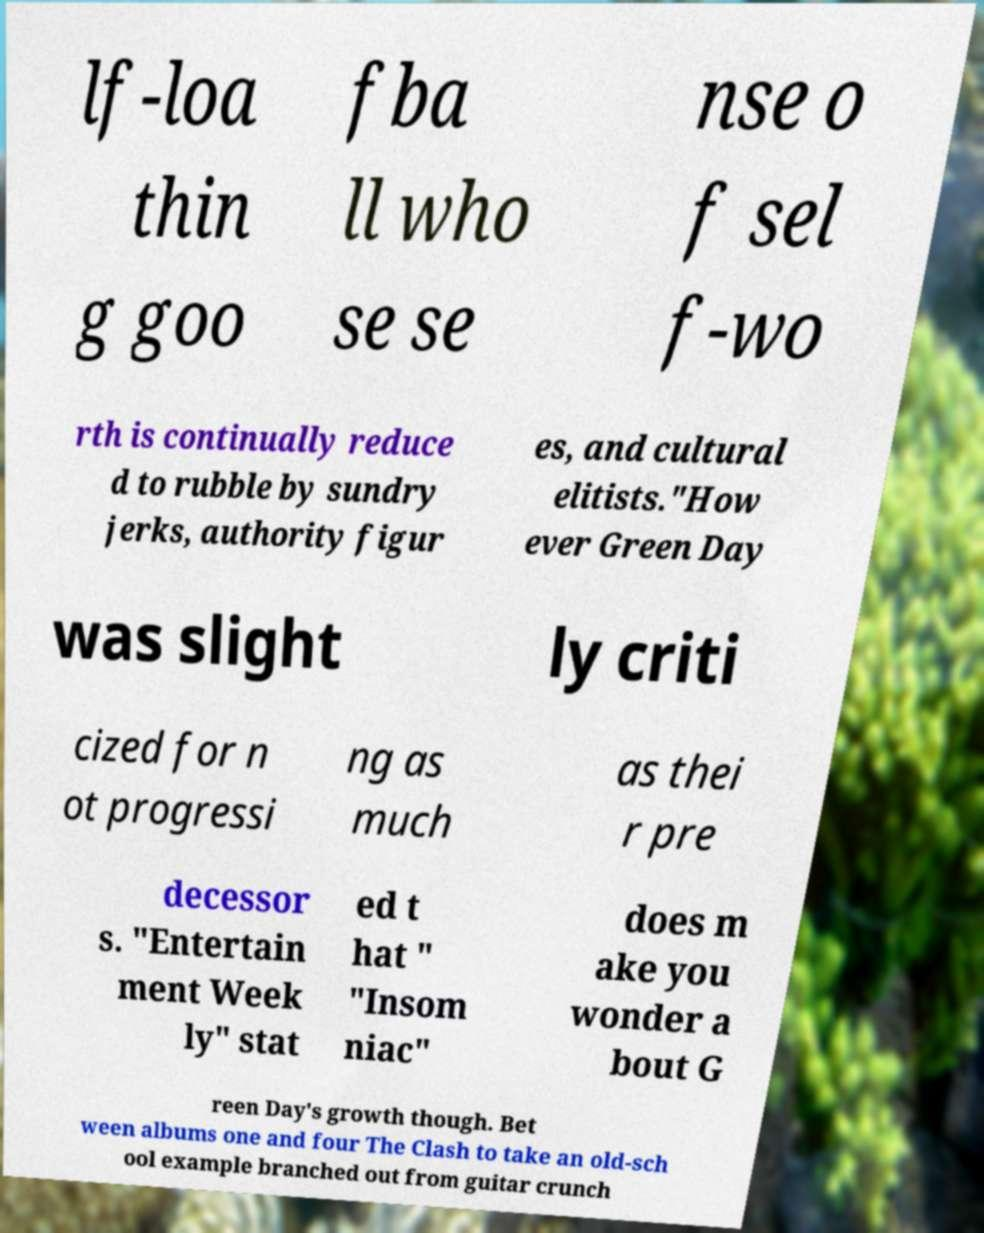Can you accurately transcribe the text from the provided image for me? lf-loa thin g goo fba ll who se se nse o f sel f-wo rth is continually reduce d to rubble by sundry jerks, authority figur es, and cultural elitists."How ever Green Day was slight ly criti cized for n ot progressi ng as much as thei r pre decessor s. "Entertain ment Week ly" stat ed t hat " "Insom niac" does m ake you wonder a bout G reen Day's growth though. Bet ween albums one and four The Clash to take an old-sch ool example branched out from guitar crunch 